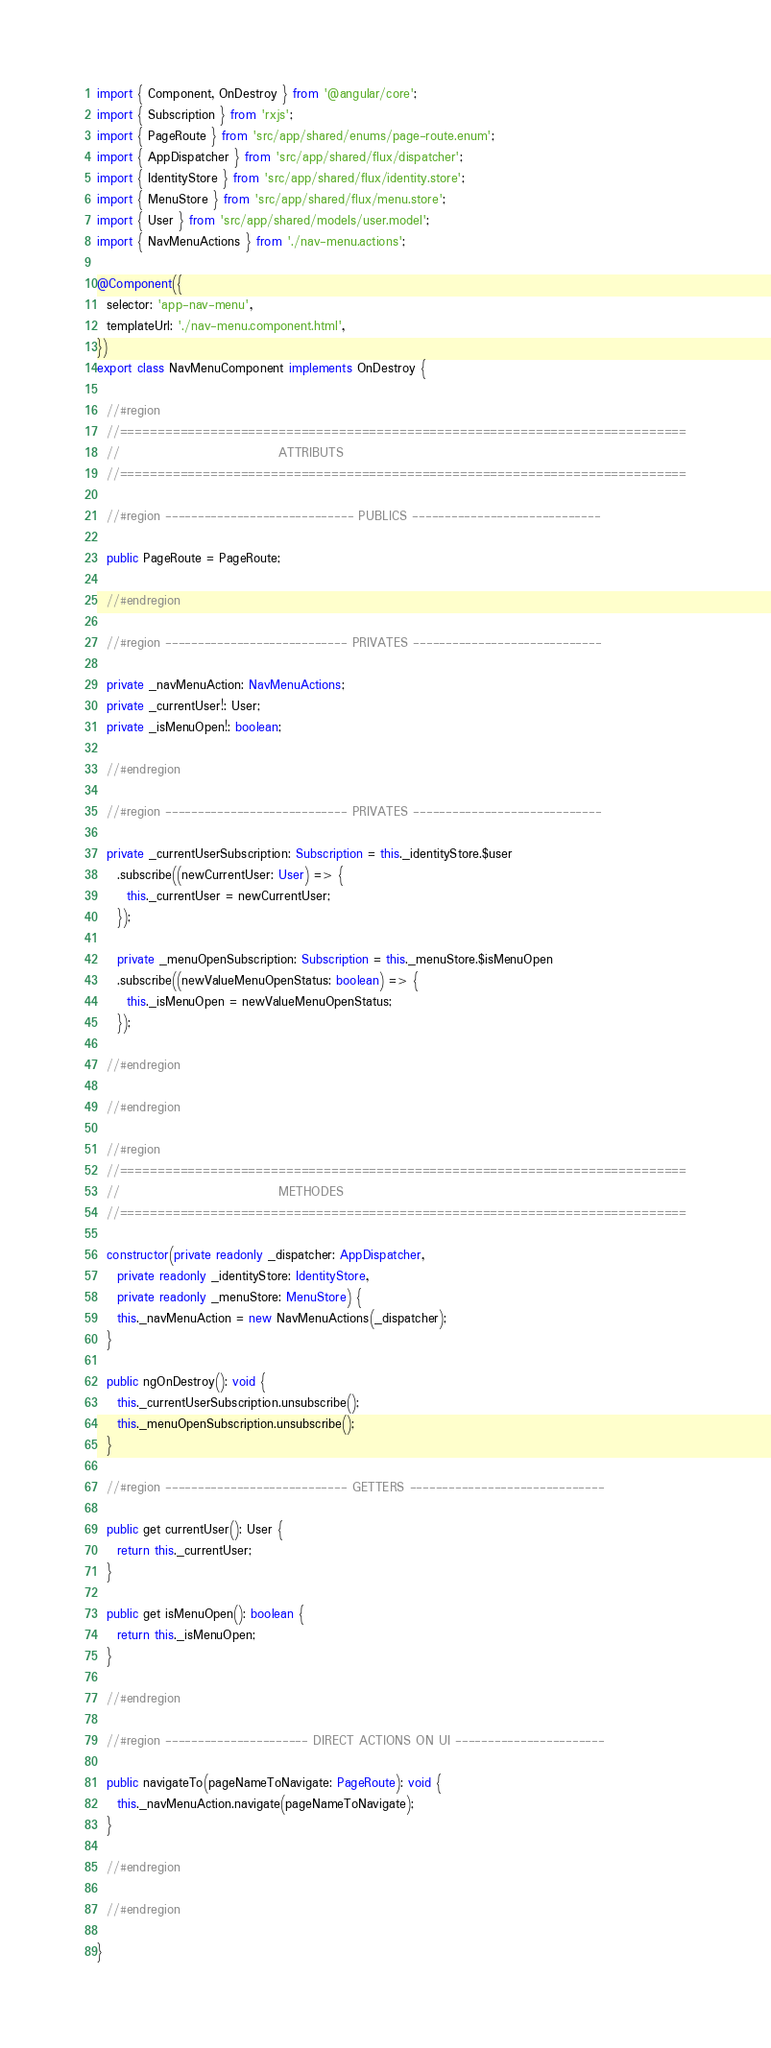<code> <loc_0><loc_0><loc_500><loc_500><_TypeScript_>import { Component, OnDestroy } from '@angular/core';
import { Subscription } from 'rxjs';
import { PageRoute } from 'src/app/shared/enums/page-route.enum';
import { AppDispatcher } from 'src/app/shared/flux/dispatcher';
import { IdentityStore } from 'src/app/shared/flux/identity.store';
import { MenuStore } from 'src/app/shared/flux/menu.store';
import { User } from 'src/app/shared/models/user.model';
import { NavMenuActions } from './nav-menu.actions';

@Component({
  selector: 'app-nav-menu',
  templateUrl: './nav-menu.component.html',
})
export class NavMenuComponent implements OnDestroy {

  //#region
  //===========================================================================
  //                                ATTRIBUTS
  //===========================================================================

  //#region ----------------------------- PUBLICS -----------------------------

  public PageRoute = PageRoute;

  //#endregion

  //#region ---------------------------- PRIVATES -----------------------------

  private _navMenuAction: NavMenuActions;
  private _currentUser!: User;
  private _isMenuOpen!: boolean;

  //#endregion

  //#region ---------------------------- PRIVATES -----------------------------

  private _currentUserSubscription: Subscription = this._identityStore.$user
    .subscribe((newCurrentUser: User) => {
      this._currentUser = newCurrentUser;
    });

    private _menuOpenSubscription: Subscription = this._menuStore.$isMenuOpen
    .subscribe((newValueMenuOpenStatus: boolean) => {
      this._isMenuOpen = newValueMenuOpenStatus;
    });

  //#endregion

  //#endregion

  //#region
  //===========================================================================
  //                                METHODES
  //===========================================================================

  constructor(private readonly _dispatcher: AppDispatcher,
    private readonly _identityStore: IdentityStore,
    private readonly _menuStore: MenuStore) {
    this._navMenuAction = new NavMenuActions(_dispatcher);
  }

  public ngOnDestroy(): void {
    this._currentUserSubscription.unsubscribe();
    this._menuOpenSubscription.unsubscribe();
  }

  //#region ---------------------------- GETTERS ------------------------------

  public get currentUser(): User {
    return this._currentUser;
  }

  public get isMenuOpen(): boolean {
    return this._isMenuOpen;
  }

  //#endregion

  //#region ---------------------- DIRECT ACTIONS ON UI -----------------------

  public navigateTo(pageNameToNavigate: PageRoute): void {
    this._navMenuAction.navigate(pageNameToNavigate);
  }

  //#endregion

  //#endregion

}
</code> 